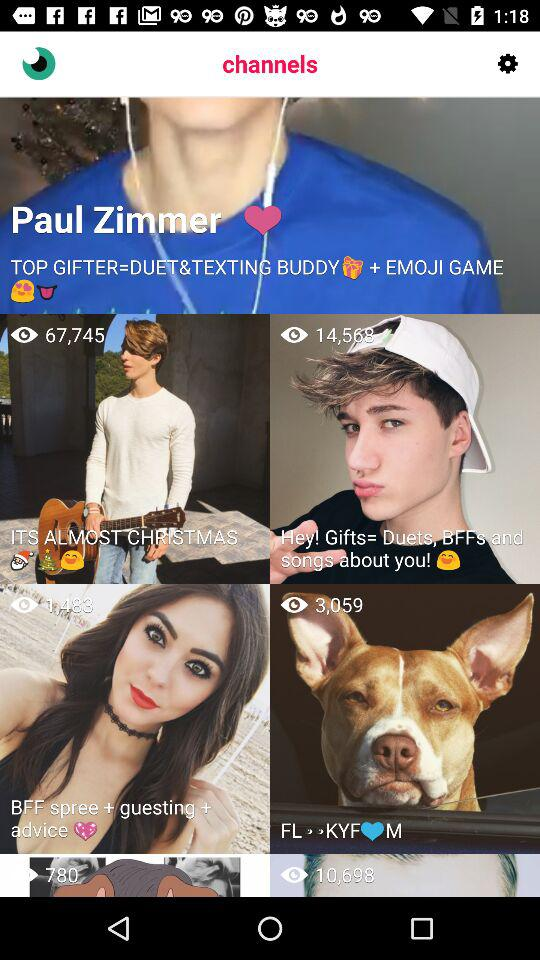How many views are there on "Hey! Gifts"? There are 14,568 views on "Hey! Gifts". 